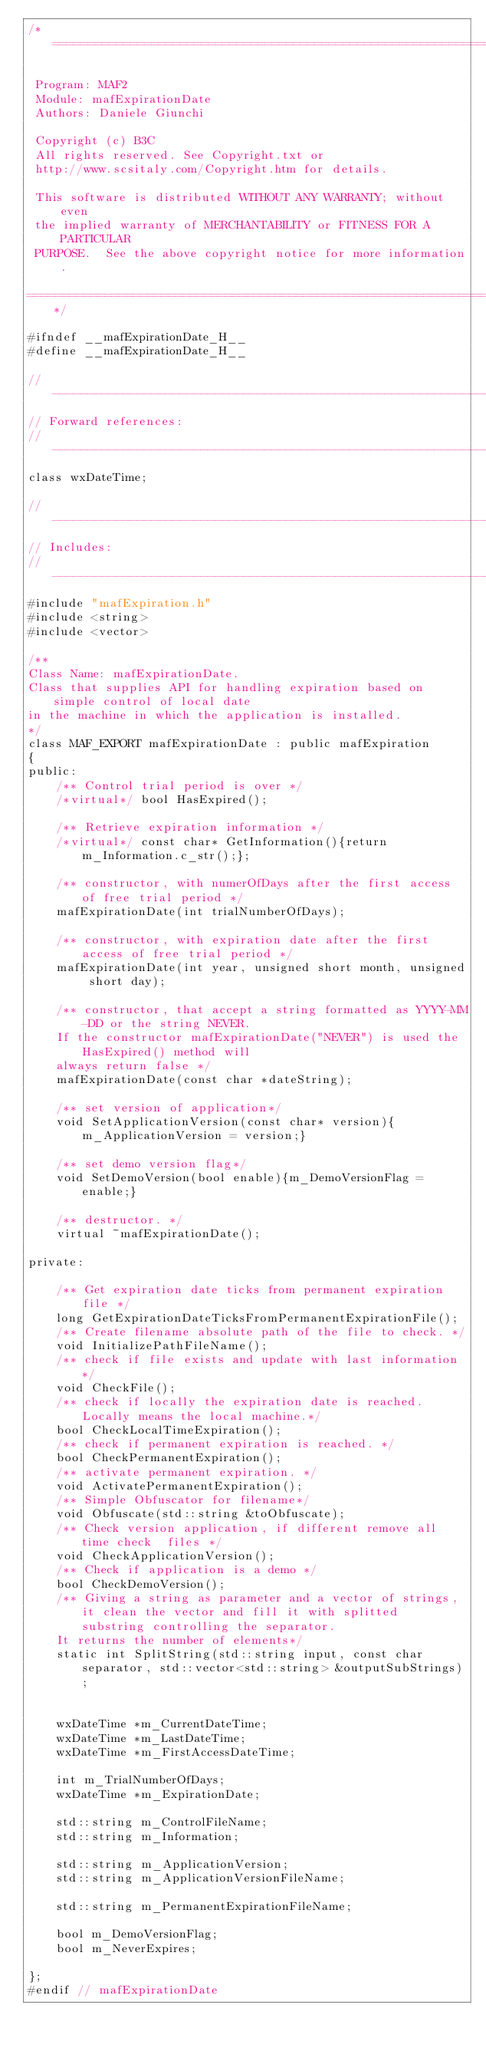Convert code to text. <code><loc_0><loc_0><loc_500><loc_500><_C_>/*=========================================================================

 Program: MAF2
 Module: mafExpirationDate
 Authors: Daniele Giunchi
 
 Copyright (c) B3C
 All rights reserved. See Copyright.txt or
 http://www.scsitaly.com/Copyright.htm for details.

 This software is distributed WITHOUT ANY WARRANTY; without even
 the implied warranty of MERCHANTABILITY or FITNESS FOR A PARTICULAR
 PURPOSE.  See the above copyright notice for more information.

=========================================================================*/

#ifndef __mafExpirationDate_H__
#define __mafExpirationDate_H__

//----------------------------------------------------------------------
// Forward references:
//----------------------------------------------------------------------
class wxDateTime;

//----------------------------------------------------------------------
// Includes:
//----------------------------------------------------------------------
#include "mafExpiration.h"
#include <string>
#include <vector>

/**
Class Name: mafExpirationDate.
Class that supplies API for handling expiration based on simple control of local date
in the machine in which the application is installed.
*/
class MAF_EXPORT mafExpirationDate : public mafExpiration
{
public:
	/** Control trial period is over */
	/*virtual*/ bool HasExpired();

	/** Retrieve expiration information */
	/*virtual*/ const char* GetInformation(){return m_Information.c_str();};

	/** constructor, with numerOfDays after the first access of free trial period */
	mafExpirationDate(int trialNumberOfDays);

	/** constructor, with expiration date after the first access of free trial period */
	mafExpirationDate(int year, unsigned short month, unsigned short day);

	/** constructor, that accept a string formatted as YYYY-MM-DD or the string NEVER. 
	If the constructor mafExpirationDate("NEVER") is used the HasExpired() method will
	always return false */ 
	mafExpirationDate(const char *dateString);

	/** set version of application*/
	void SetApplicationVersion(const char* version){m_ApplicationVersion = version;}

	/** set demo version flag*/
	void SetDemoVersion(bool enable){m_DemoVersionFlag = enable;}

	/** destructor. */
	virtual ~mafExpirationDate();

private:

	/** Get expiration date ticks from permanent expiration file */
	long GetExpirationDateTicksFromPermanentExpirationFile();
	/** Create filename absolute path of the file to check. */
	void InitializePathFileName();
	/** check if file exists and update with last information*/
	void CheckFile();
	/** check if locally the expiration date is reached. Locally means the local machine.*/
	bool CheckLocalTimeExpiration();
	/** check if permanent expiration is reached. */
	bool CheckPermanentExpiration();
	/** activate permanent expiration. */
	void ActivatePermanentExpiration();
	/** Simple Obfuscator for filename*/
	void Obfuscate(std::string &toObfuscate);
	/** Check version application, if different remove all time check  files */
	void CheckApplicationVersion();
	/** Check if application is a demo */
	bool CheckDemoVersion();
	/** Giving a string as parameter and a vector of strings, it clean the vector and fill it with splitted substring controlling the separator.
	It returns the number of elements*/
	static int SplitString(std::string input, const char separator, std::vector<std::string> &outputSubStrings);


	wxDateTime *m_CurrentDateTime;
	wxDateTime *m_LastDateTime;
	wxDateTime *m_FirstAccessDateTime;

	int m_TrialNumberOfDays;
	wxDateTime *m_ExpirationDate;

	std::string m_ControlFileName;
	std::string m_Information;

	std::string m_ApplicationVersion;
	std::string m_ApplicationVersionFileName;

	std::string m_PermanentExpirationFileName;

	bool m_DemoVersionFlag;
	bool m_NeverExpires;

};
#endif // mafExpirationDate</code> 